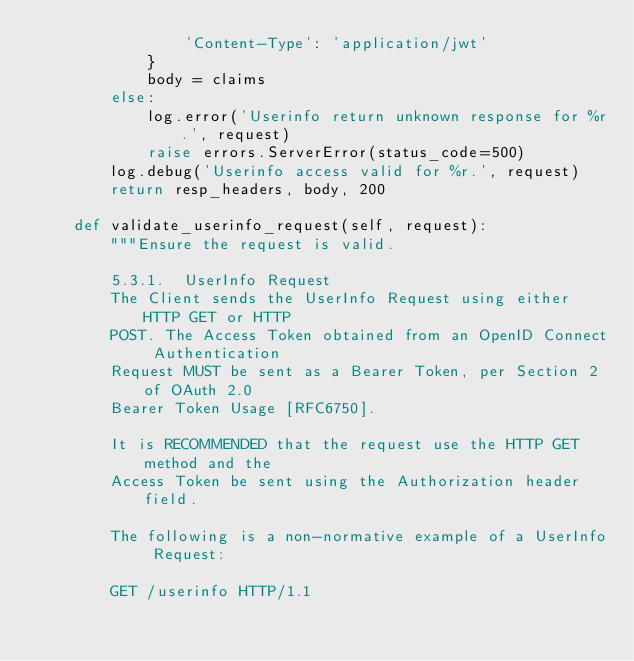Convert code to text. <code><loc_0><loc_0><loc_500><loc_500><_Python_>                'Content-Type': 'application/jwt'
            }
            body = claims
        else:
            log.error('Userinfo return unknown response for %r.', request)
            raise errors.ServerError(status_code=500)
        log.debug('Userinfo access valid for %r.', request)
        return resp_headers, body, 200

    def validate_userinfo_request(self, request):
        """Ensure the request is valid.

        5.3.1.  UserInfo Request
        The Client sends the UserInfo Request using either HTTP GET or HTTP
        POST. The Access Token obtained from an OpenID Connect Authentication
        Request MUST be sent as a Bearer Token, per Section 2 of OAuth 2.0
        Bearer Token Usage [RFC6750].

        It is RECOMMENDED that the request use the HTTP GET method and the
        Access Token be sent using the Authorization header field.

        The following is a non-normative example of a UserInfo Request:

        GET /userinfo HTTP/1.1</code> 